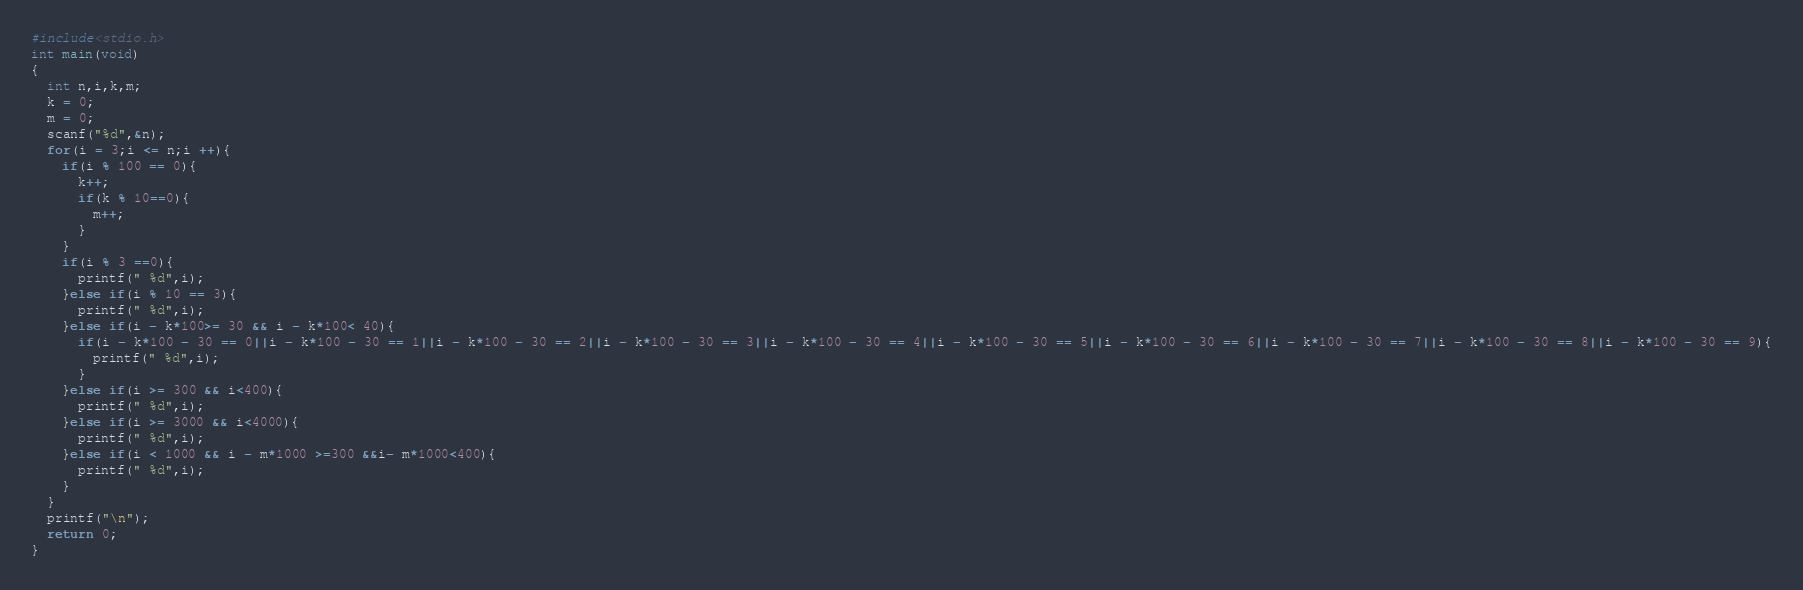Convert code to text. <code><loc_0><loc_0><loc_500><loc_500><_C_>#include<stdio.h>
int main(void)
{
  int n,i,k,m;
  k = 0;
  m = 0;
  scanf("%d",&n);
  for(i = 3;i <= n;i ++){
    if(i % 100 == 0){
      k++;
      if(k % 10==0){
        m++;
      }
    }
    if(i % 3 ==0){
      printf(" %d",i);
    }else if(i % 10 == 3){
      printf(" %d",i);
    }else if(i - k*100>= 30 && i - k*100< 40){
      if(i - k*100 - 30 == 0||i - k*100 - 30 == 1||i - k*100 - 30 == 2||i - k*100 - 30 == 3||i - k*100 - 30 == 4||i - k*100 - 30 == 5||i - k*100 - 30 == 6||i - k*100 - 30 == 7||i - k*100 - 30 == 8||i - k*100 - 30 == 9){
        printf(" %d",i);
      }
    }else if(i >= 300 && i<400){
      printf(" %d",i);
    }else if(i >= 3000 && i<4000){
      printf(" %d",i);
    }else if(i < 1000 && i - m*1000 >=300 &&i- m*1000<400){
      printf(" %d",i);
    }
  }
  printf("\n");
  return 0;
}</code> 